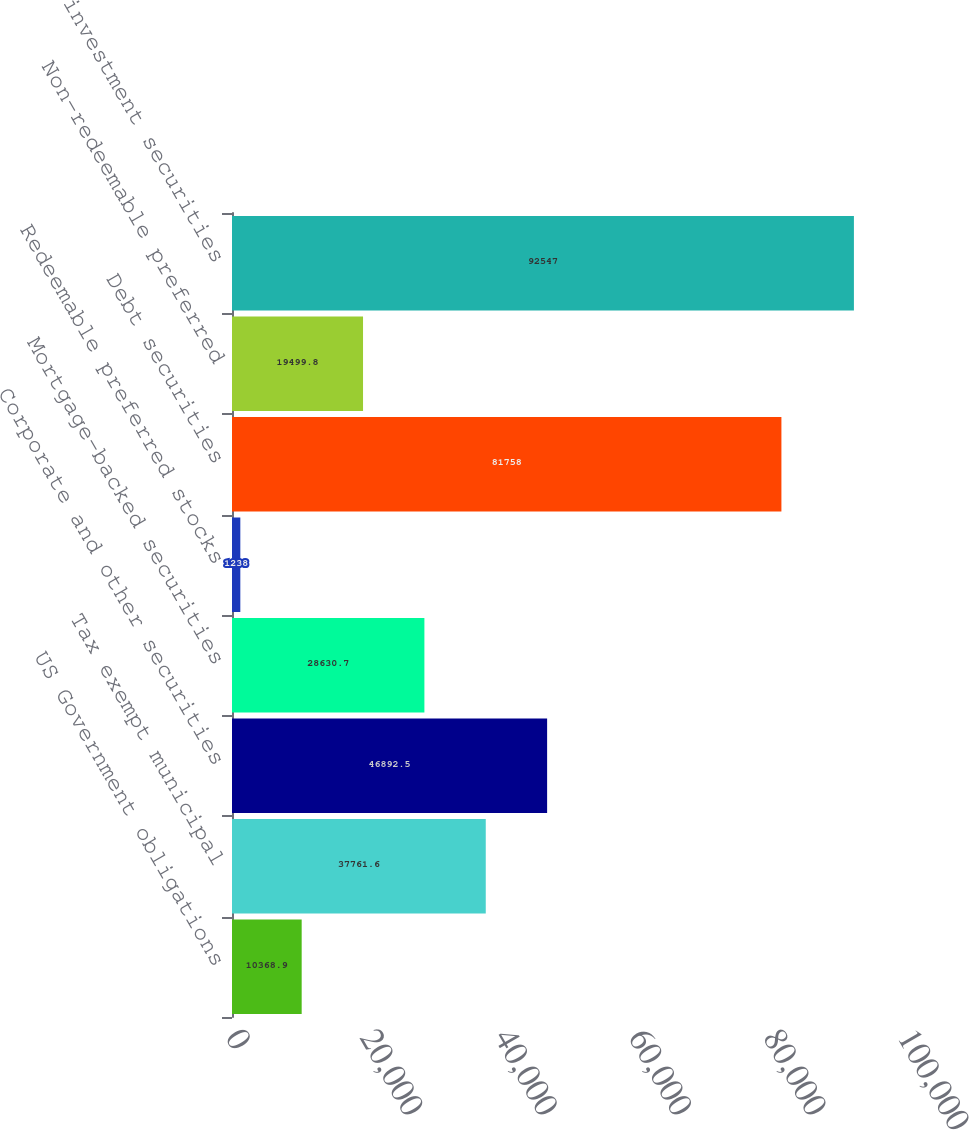Convert chart to OTSL. <chart><loc_0><loc_0><loc_500><loc_500><bar_chart><fcel>US Government obligations<fcel>Tax exempt municipal<fcel>Corporate and other securities<fcel>Mortgage-backed securities<fcel>Redeemable preferred stocks<fcel>Debt securities<fcel>Non-redeemable preferred<fcel>Total investment securities<nl><fcel>10368.9<fcel>37761.6<fcel>46892.5<fcel>28630.7<fcel>1238<fcel>81758<fcel>19499.8<fcel>92547<nl></chart> 